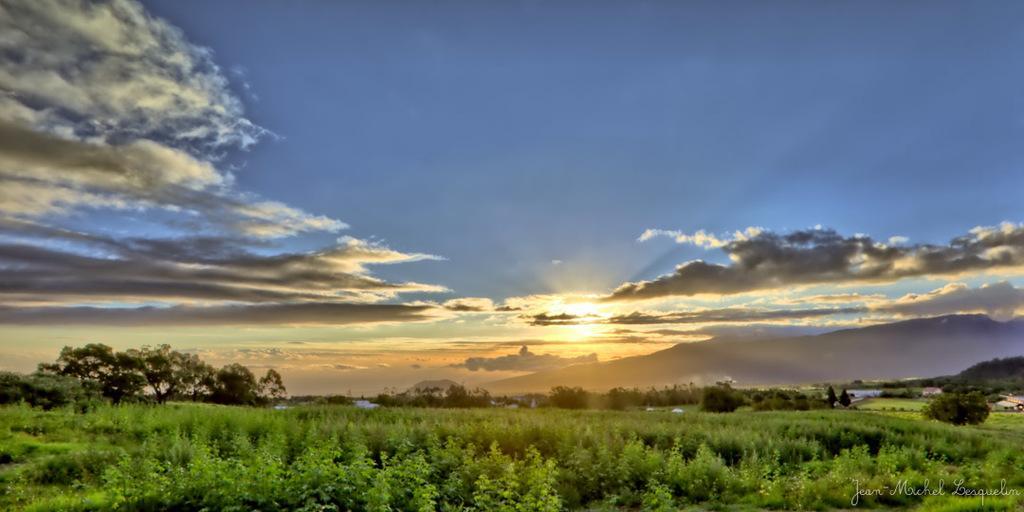Can you describe this image briefly? In this image I can see sunset at the top of the image I can see the sky and at the bottom of the image I can see trees and in the right bottom corner I can see some text. 